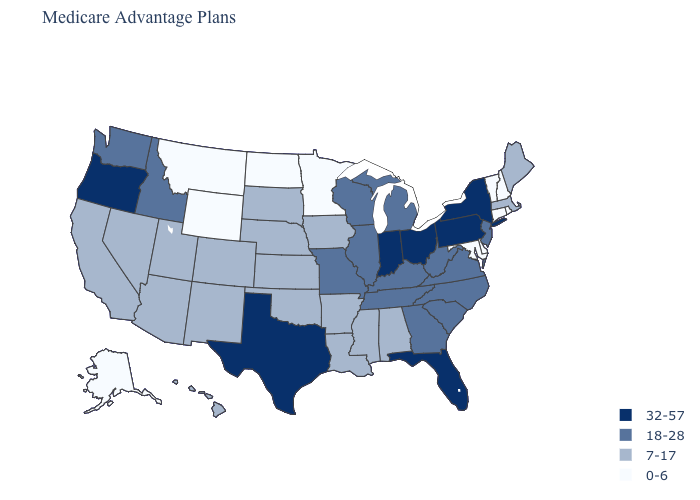What is the value of Hawaii?
Short answer required. 7-17. Does Hawaii have a higher value than Georgia?
Give a very brief answer. No. Name the states that have a value in the range 7-17?
Be succinct. Alabama, Arizona, Arkansas, California, Colorado, Hawaii, Iowa, Kansas, Louisiana, Maine, Massachusetts, Mississippi, Nebraska, Nevada, New Mexico, Oklahoma, South Dakota, Utah. Which states have the highest value in the USA?
Concise answer only. Florida, Indiana, New York, Ohio, Oregon, Pennsylvania, Texas. What is the lowest value in the Northeast?
Keep it brief. 0-6. What is the highest value in the West ?
Quick response, please. 32-57. Which states have the lowest value in the USA?
Answer briefly. Alaska, Connecticut, Delaware, Maryland, Minnesota, Montana, New Hampshire, North Dakota, Rhode Island, Vermont, Wyoming. Does Colorado have the lowest value in the USA?
Quick response, please. No. What is the value of Virginia?
Short answer required. 18-28. Name the states that have a value in the range 18-28?
Answer briefly. Georgia, Idaho, Illinois, Kentucky, Michigan, Missouri, New Jersey, North Carolina, South Carolina, Tennessee, Virginia, Washington, West Virginia, Wisconsin. Name the states that have a value in the range 0-6?
Answer briefly. Alaska, Connecticut, Delaware, Maryland, Minnesota, Montana, New Hampshire, North Dakota, Rhode Island, Vermont, Wyoming. What is the value of New York?
Be succinct. 32-57. What is the value of Maine?
Short answer required. 7-17. Does the map have missing data?
Concise answer only. No. 